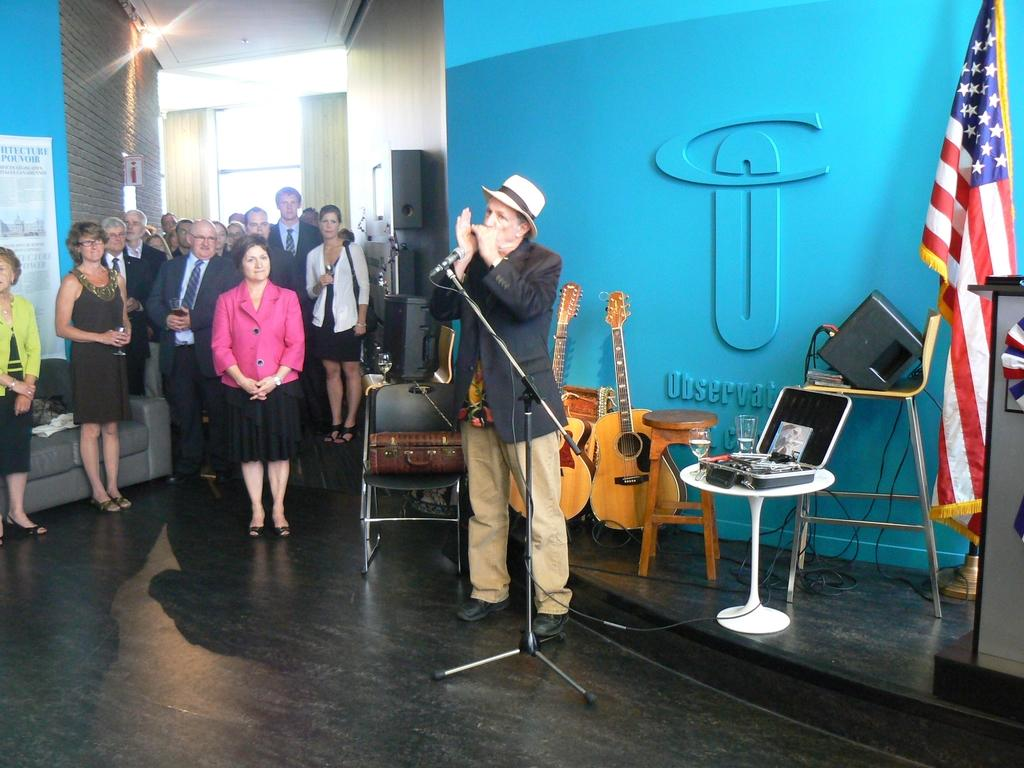What is the color of the wall in the image? The wall in the image is blue. What electronic device can be seen in the image? There is a laptop in the image. What musical instrument is present in the image? There is a guitar in the image. What device is used for amplifying sound in the image? There is a microphone (mike) in the image. How many people are standing on the floor in the image? There are people standing on the floor in the image. What type of doctor is standing near the guitar in the image? There is no doctor present in the image; it features a wall, laptop, guitar, microphone, and people standing on the floor. What season is depicted in the image? The provided facts do not mention any seasonal details, so it cannot be determined from the image. 